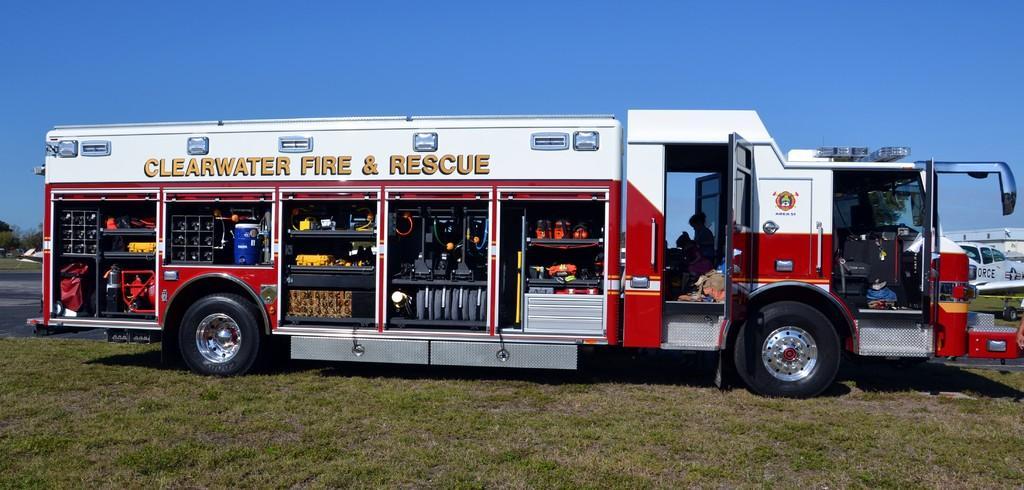In one or two sentences, can you explain what this image depicts? In this image we can see a fire rescue truck. At the bottom of the image there is grass. At the top of the image there is sky. To the left side of the image there is road. 